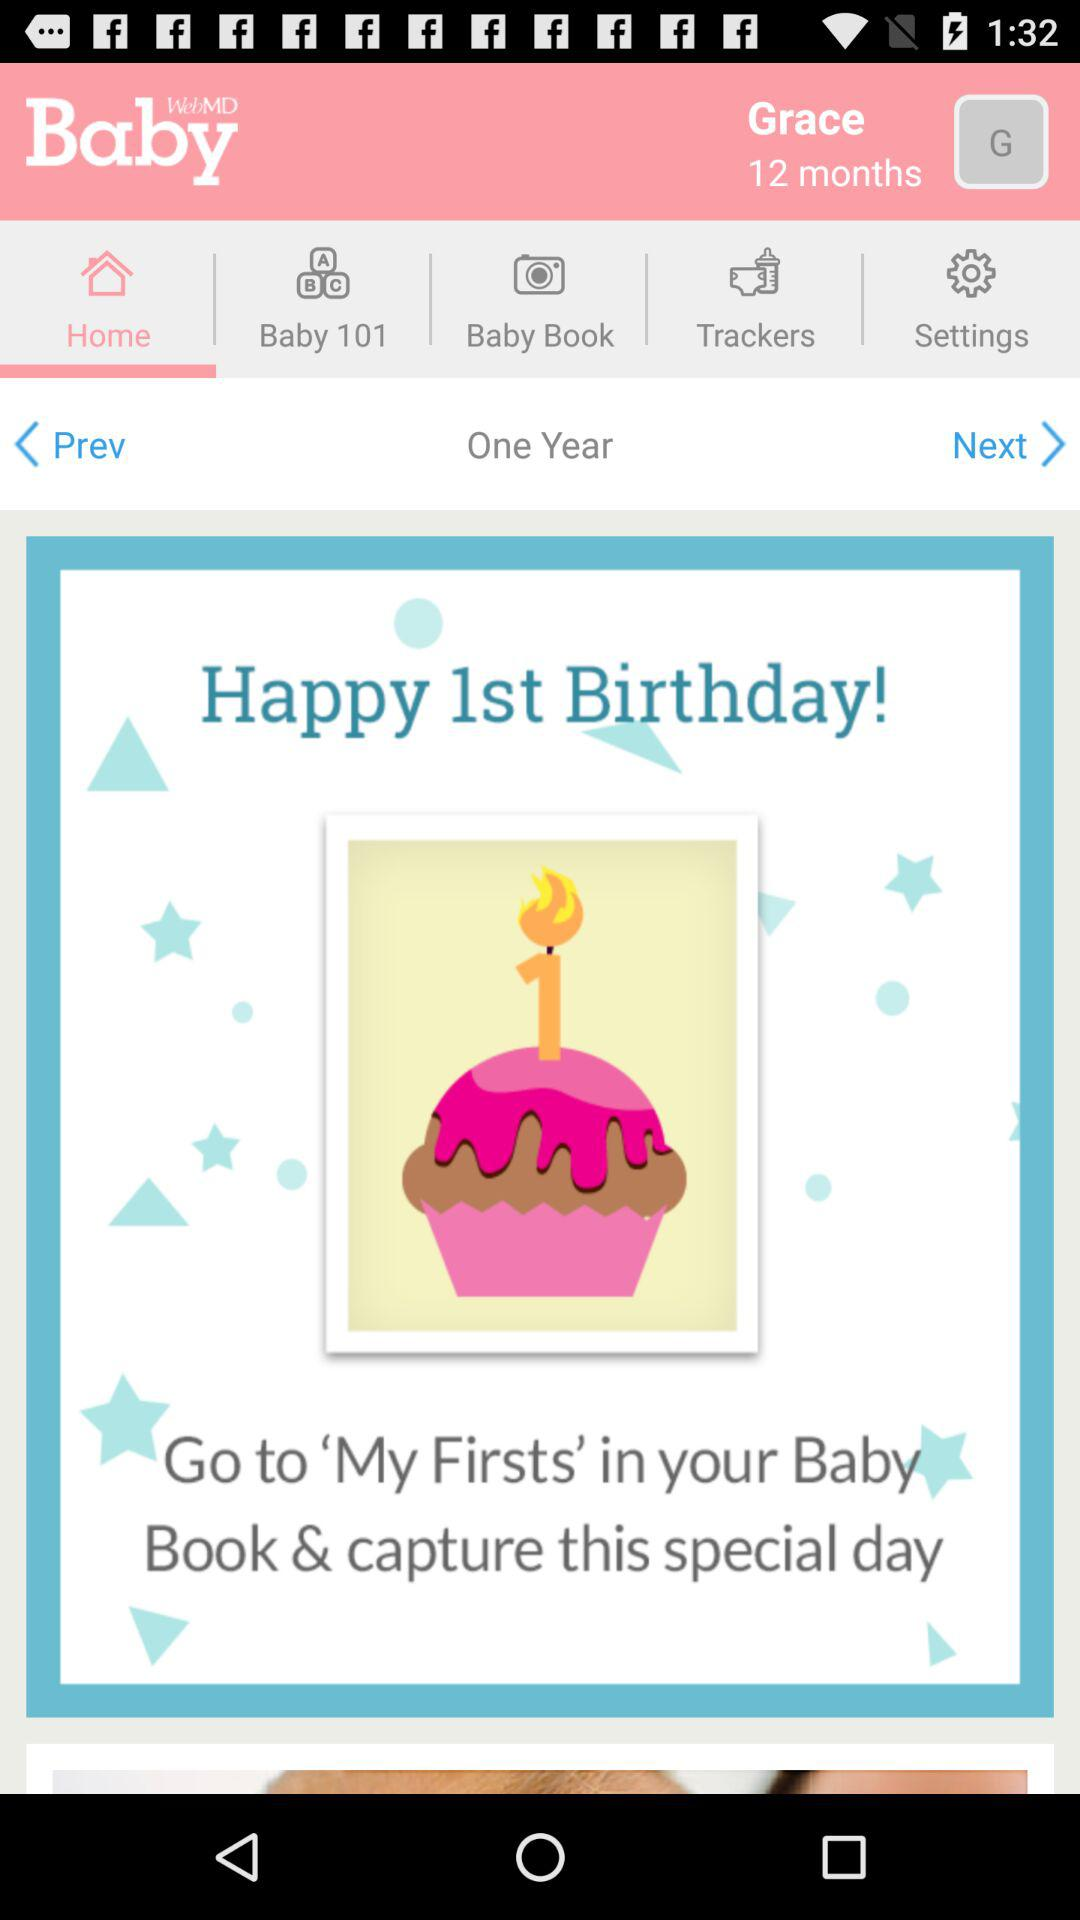Which tab is selected? The selected tab is "Home". 